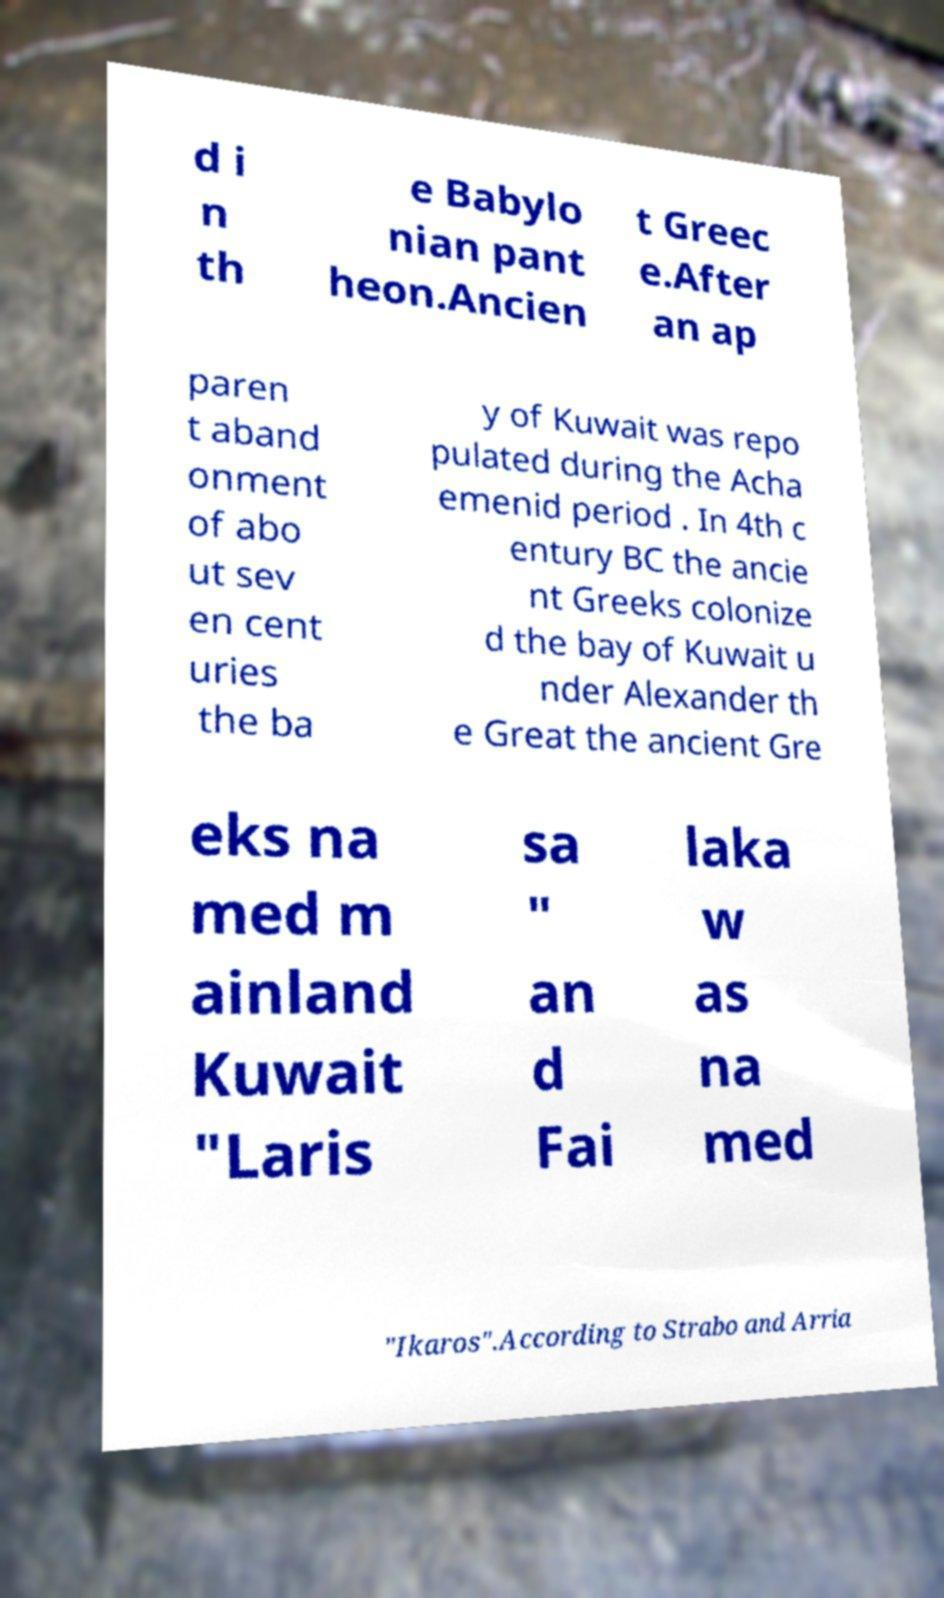Could you extract and type out the text from this image? d i n th e Babylo nian pant heon.Ancien t Greec e.After an ap paren t aband onment of abo ut sev en cent uries the ba y of Kuwait was repo pulated during the Acha emenid period . In 4th c entury BC the ancie nt Greeks colonize d the bay of Kuwait u nder Alexander th e Great the ancient Gre eks na med m ainland Kuwait "Laris sa " an d Fai laka w as na med "Ikaros".According to Strabo and Arria 